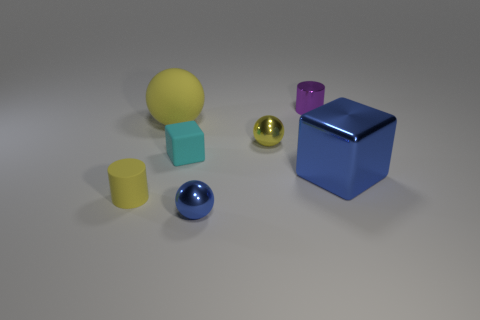Are there any small purple metal cylinders behind the tiny blue shiny sphere?
Your answer should be very brief. Yes. Is the number of large red shiny blocks greater than the number of large blue blocks?
Keep it short and to the point. No. What color is the metal sphere behind the tiny metal ball that is in front of the tiny yellow object behind the yellow rubber cylinder?
Offer a very short reply. Yellow. The large object that is made of the same material as the tiny yellow cylinder is what color?
Give a very brief answer. Yellow. Are there any other things that have the same size as the yellow cylinder?
Give a very brief answer. Yes. What number of objects are objects that are left of the blue metallic sphere or things that are behind the big ball?
Provide a short and direct response. 4. Does the rubber thing that is behind the tiny yellow shiny sphere have the same size as the yellow rubber object to the left of the matte sphere?
Provide a succinct answer. No. What is the color of the small rubber thing that is the same shape as the small purple shiny object?
Your response must be concise. Yellow. Are there any other things that are the same shape as the purple object?
Make the answer very short. Yes. Is the number of large shiny blocks that are on the left side of the shiny cylinder greater than the number of large blue objects that are left of the blue sphere?
Your answer should be compact. No. 